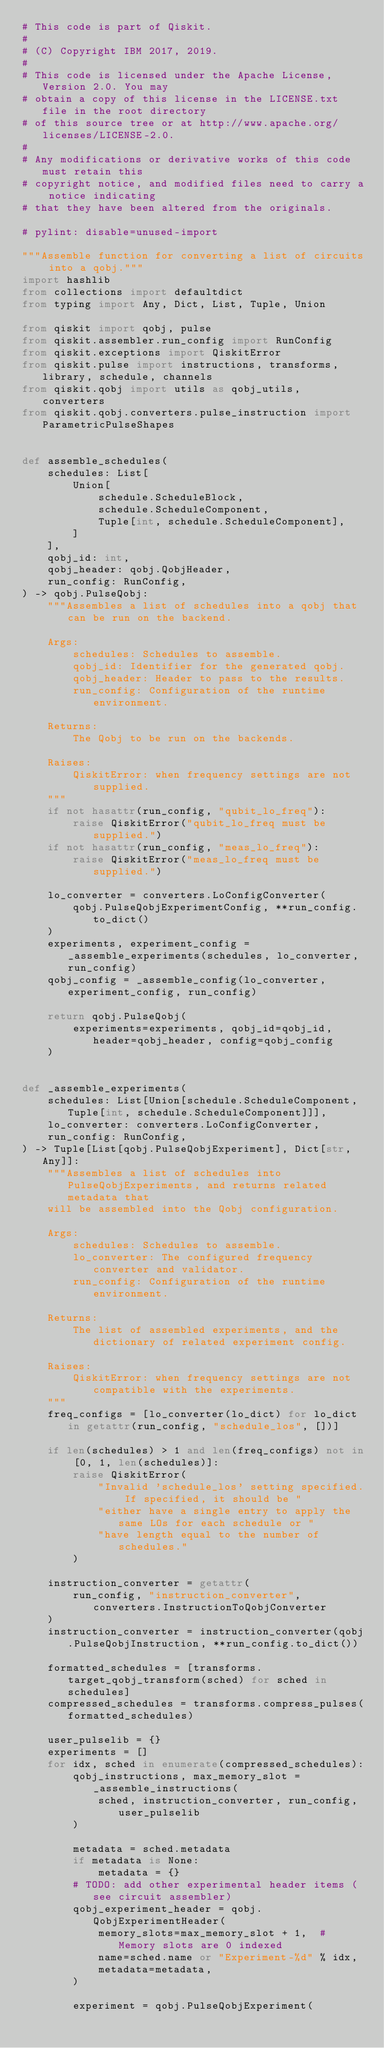<code> <loc_0><loc_0><loc_500><loc_500><_Python_># This code is part of Qiskit.
#
# (C) Copyright IBM 2017, 2019.
#
# This code is licensed under the Apache License, Version 2.0. You may
# obtain a copy of this license in the LICENSE.txt file in the root directory
# of this source tree or at http://www.apache.org/licenses/LICENSE-2.0.
#
# Any modifications or derivative works of this code must retain this
# copyright notice, and modified files need to carry a notice indicating
# that they have been altered from the originals.

# pylint: disable=unused-import

"""Assemble function for converting a list of circuits into a qobj."""
import hashlib
from collections import defaultdict
from typing import Any, Dict, List, Tuple, Union

from qiskit import qobj, pulse
from qiskit.assembler.run_config import RunConfig
from qiskit.exceptions import QiskitError
from qiskit.pulse import instructions, transforms, library, schedule, channels
from qiskit.qobj import utils as qobj_utils, converters
from qiskit.qobj.converters.pulse_instruction import ParametricPulseShapes


def assemble_schedules(
    schedules: List[
        Union[
            schedule.ScheduleBlock,
            schedule.ScheduleComponent,
            Tuple[int, schedule.ScheduleComponent],
        ]
    ],
    qobj_id: int,
    qobj_header: qobj.QobjHeader,
    run_config: RunConfig,
) -> qobj.PulseQobj:
    """Assembles a list of schedules into a qobj that can be run on the backend.

    Args:
        schedules: Schedules to assemble.
        qobj_id: Identifier for the generated qobj.
        qobj_header: Header to pass to the results.
        run_config: Configuration of the runtime environment.

    Returns:
        The Qobj to be run on the backends.

    Raises:
        QiskitError: when frequency settings are not supplied.
    """
    if not hasattr(run_config, "qubit_lo_freq"):
        raise QiskitError("qubit_lo_freq must be supplied.")
    if not hasattr(run_config, "meas_lo_freq"):
        raise QiskitError("meas_lo_freq must be supplied.")

    lo_converter = converters.LoConfigConverter(
        qobj.PulseQobjExperimentConfig, **run_config.to_dict()
    )
    experiments, experiment_config = _assemble_experiments(schedules, lo_converter, run_config)
    qobj_config = _assemble_config(lo_converter, experiment_config, run_config)

    return qobj.PulseQobj(
        experiments=experiments, qobj_id=qobj_id, header=qobj_header, config=qobj_config
    )


def _assemble_experiments(
    schedules: List[Union[schedule.ScheduleComponent, Tuple[int, schedule.ScheduleComponent]]],
    lo_converter: converters.LoConfigConverter,
    run_config: RunConfig,
) -> Tuple[List[qobj.PulseQobjExperiment], Dict[str, Any]]:
    """Assembles a list of schedules into PulseQobjExperiments, and returns related metadata that
    will be assembled into the Qobj configuration.

    Args:
        schedules: Schedules to assemble.
        lo_converter: The configured frequency converter and validator.
        run_config: Configuration of the runtime environment.

    Returns:
        The list of assembled experiments, and the dictionary of related experiment config.

    Raises:
        QiskitError: when frequency settings are not compatible with the experiments.
    """
    freq_configs = [lo_converter(lo_dict) for lo_dict in getattr(run_config, "schedule_los", [])]

    if len(schedules) > 1 and len(freq_configs) not in [0, 1, len(schedules)]:
        raise QiskitError(
            "Invalid 'schedule_los' setting specified. If specified, it should be "
            "either have a single entry to apply the same LOs for each schedule or "
            "have length equal to the number of schedules."
        )

    instruction_converter = getattr(
        run_config, "instruction_converter", converters.InstructionToQobjConverter
    )
    instruction_converter = instruction_converter(qobj.PulseQobjInstruction, **run_config.to_dict())

    formatted_schedules = [transforms.target_qobj_transform(sched) for sched in schedules]
    compressed_schedules = transforms.compress_pulses(formatted_schedules)

    user_pulselib = {}
    experiments = []
    for idx, sched in enumerate(compressed_schedules):
        qobj_instructions, max_memory_slot = _assemble_instructions(
            sched, instruction_converter, run_config, user_pulselib
        )

        metadata = sched.metadata
        if metadata is None:
            metadata = {}
        # TODO: add other experimental header items (see circuit assembler)
        qobj_experiment_header = qobj.QobjExperimentHeader(
            memory_slots=max_memory_slot + 1,  # Memory slots are 0 indexed
            name=sched.name or "Experiment-%d" % idx,
            metadata=metadata,
        )

        experiment = qobj.PulseQobjExperiment(</code> 